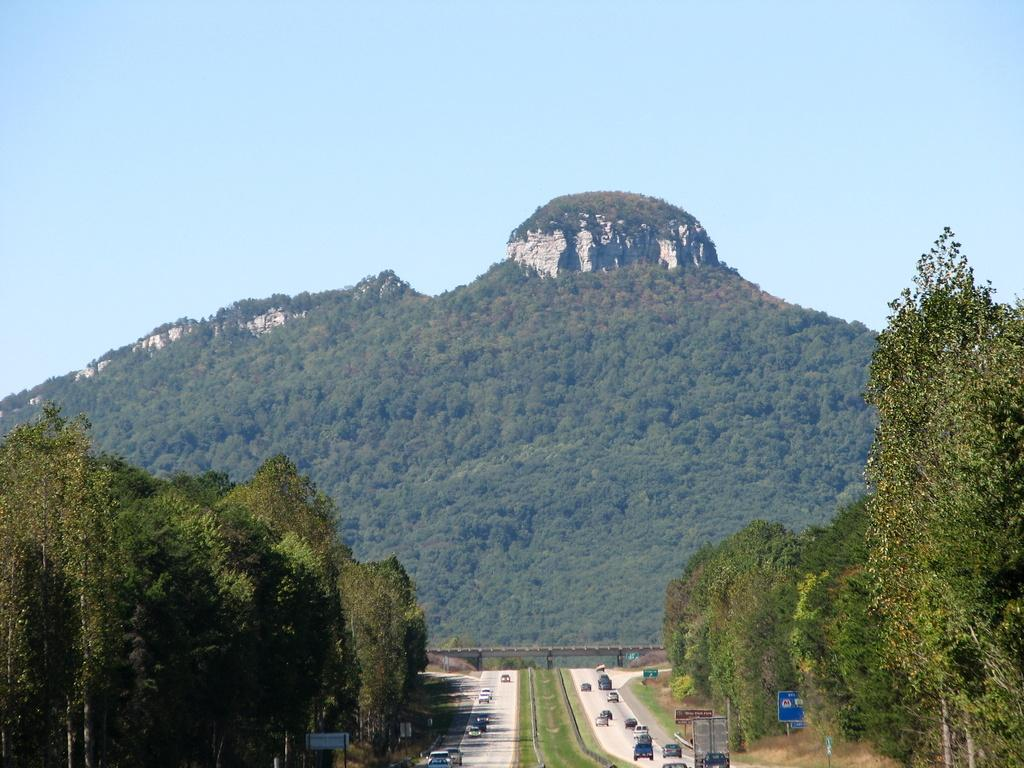What can be seen on the road in the image? There are vehicles on the road in the image. What is present on the left and right sides of the image? There are blue color boards on the left and right sides of the image. How are the blue color boards positioned in the image? The blue color boards are attached to poles. What is visible in the background of the image? There are trees and the sky in the background of the image. What is the color of the trees in the image? The trees are green in color. What is the color of the sky in the image? The sky is blue in color. How many pizzas are being delivered by the vehicles in the image? There is no information about pizzas or deliveries in the image. What type of pets can be seen playing near the trees in the image? There are no pets visible in the image. 